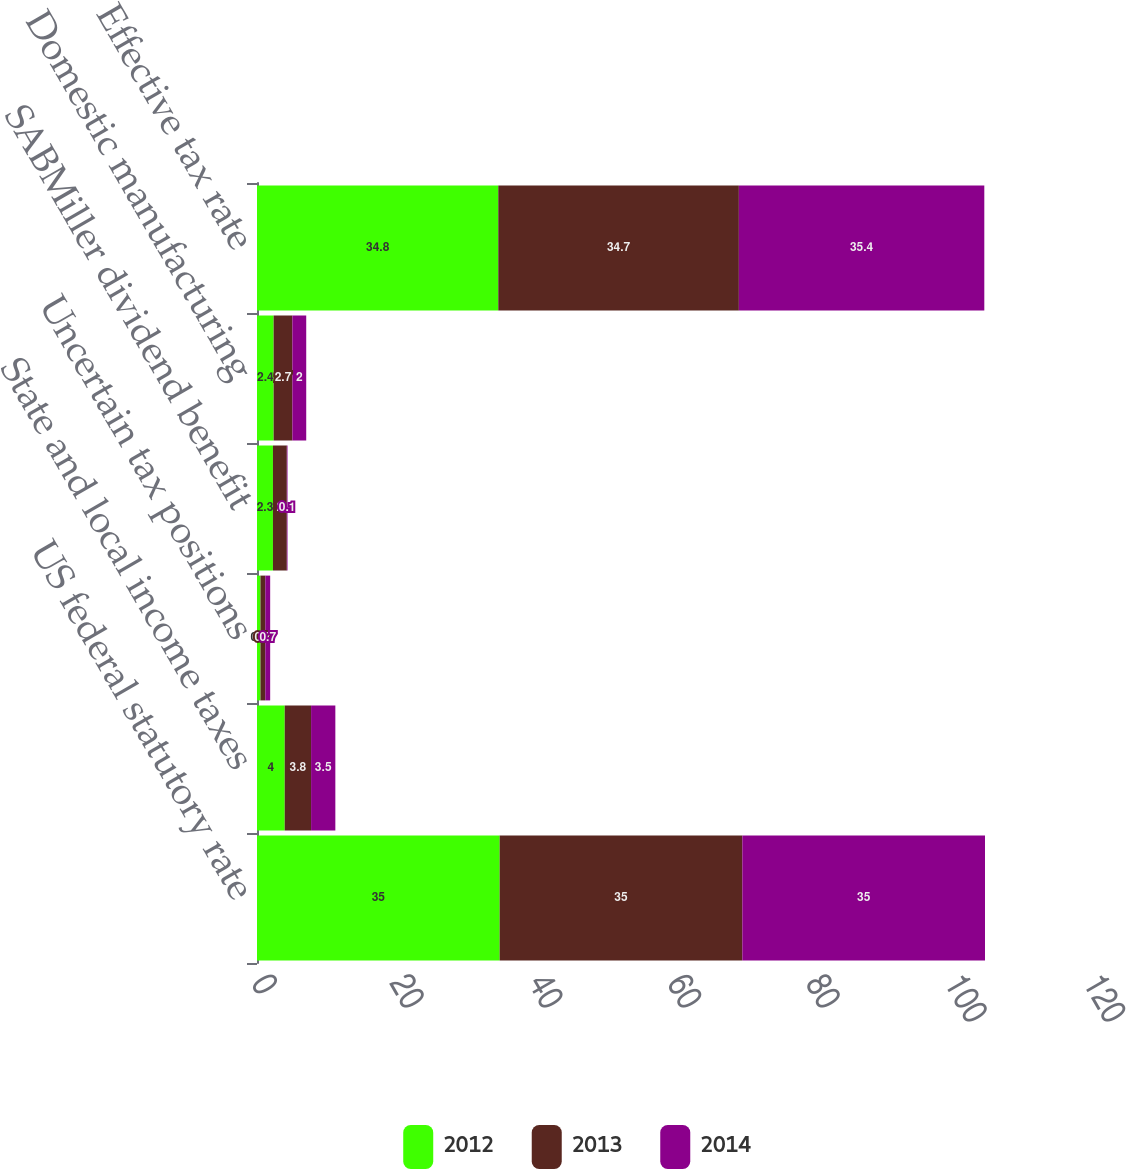Convert chart to OTSL. <chart><loc_0><loc_0><loc_500><loc_500><stacked_bar_chart><ecel><fcel>US federal statutory rate<fcel>State and local income taxes<fcel>Uncertain tax positions<fcel>SABMiller dividend benefit<fcel>Domestic manufacturing<fcel>Effective tax rate<nl><fcel>2012<fcel>35<fcel>4<fcel>0.5<fcel>2.3<fcel>2.4<fcel>34.8<nl><fcel>2013<fcel>35<fcel>3.8<fcel>0.7<fcel>2<fcel>2.7<fcel>34.7<nl><fcel>2014<fcel>35<fcel>3.5<fcel>0.7<fcel>0.1<fcel>2<fcel>35.4<nl></chart> 